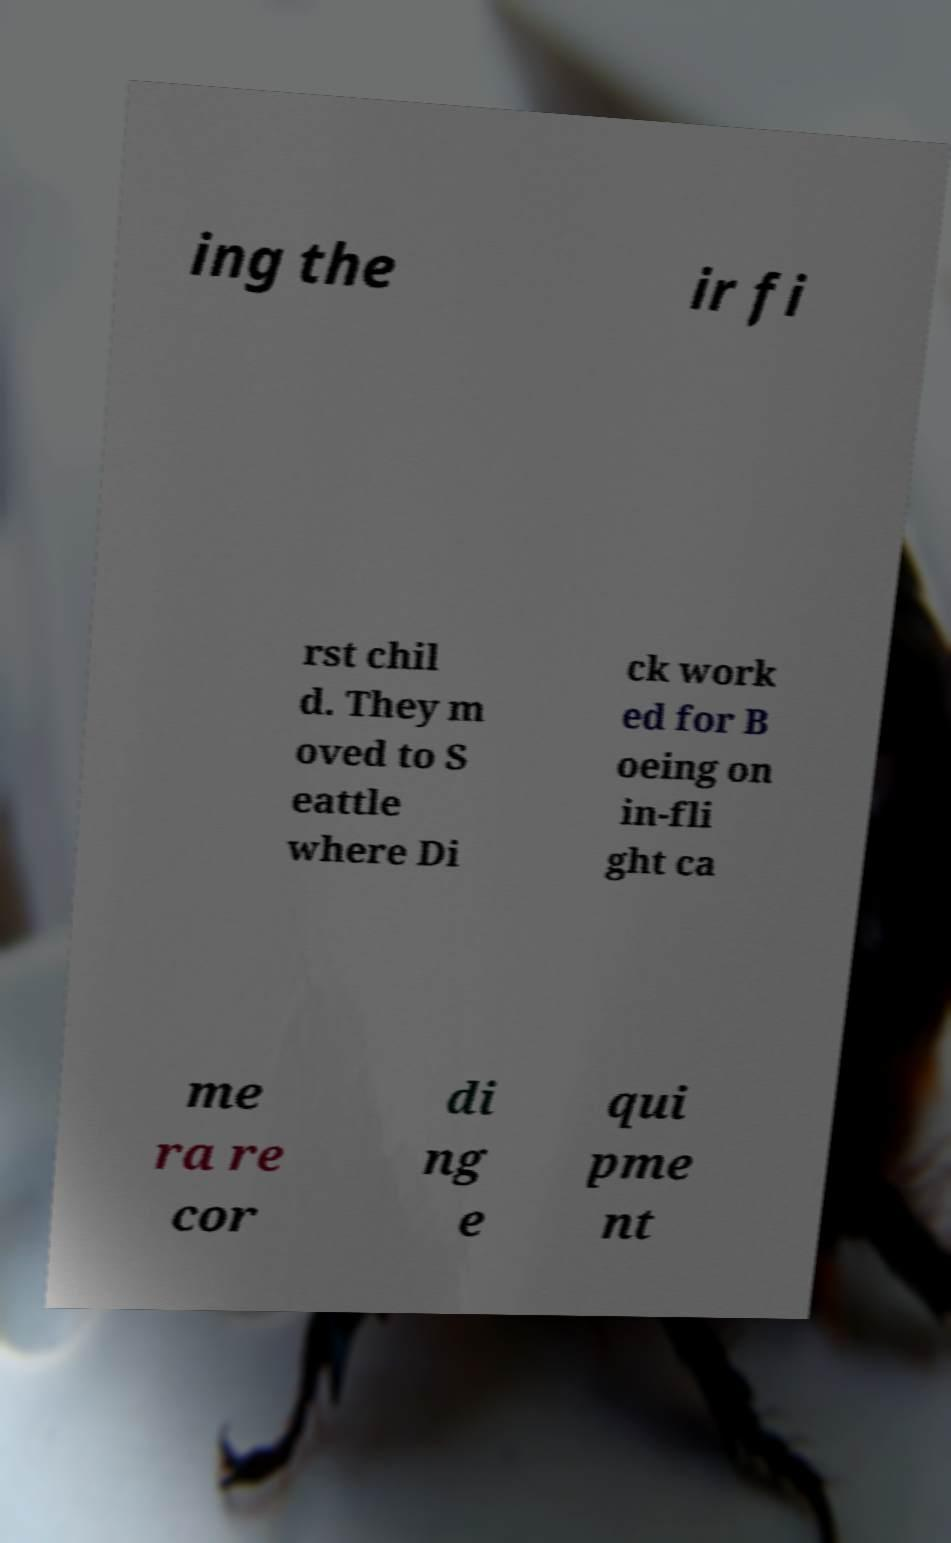For documentation purposes, I need the text within this image transcribed. Could you provide that? ing the ir fi rst chil d. They m oved to S eattle where Di ck work ed for B oeing on in-fli ght ca me ra re cor di ng e qui pme nt 